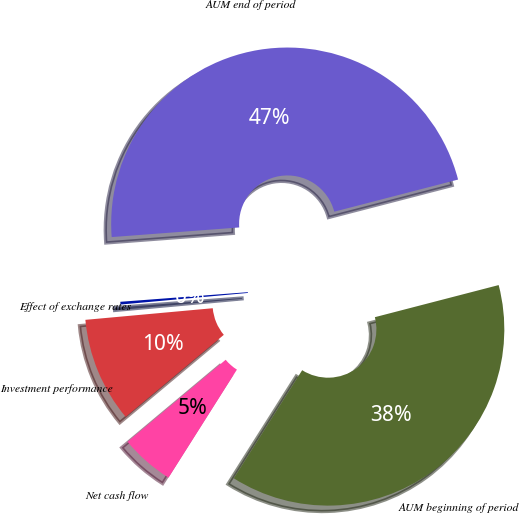Convert chart. <chart><loc_0><loc_0><loc_500><loc_500><pie_chart><fcel>AUM beginning of period<fcel>Net cash flow<fcel>Investment performance<fcel>Effect of exchange rates<fcel>AUM end of period<nl><fcel>38.02%<fcel>4.94%<fcel>9.63%<fcel>0.25%<fcel>47.16%<nl></chart> 